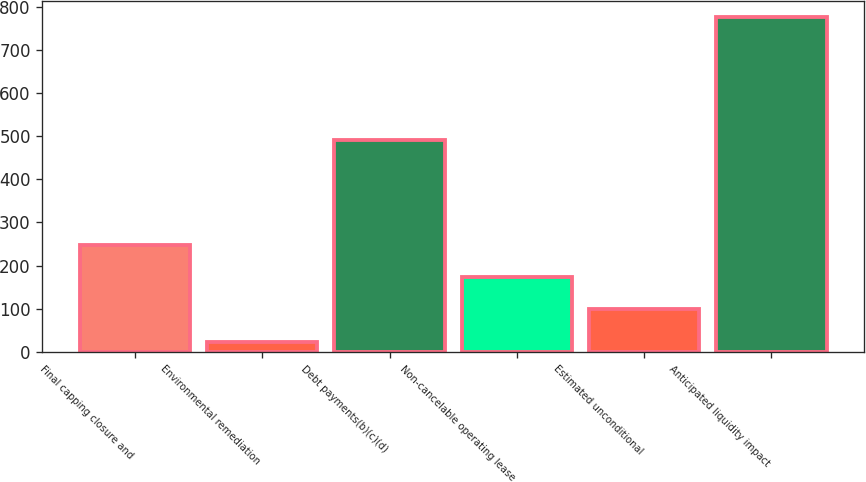Convert chart. <chart><loc_0><loc_0><loc_500><loc_500><bar_chart><fcel>Final capping closure and<fcel>Environmental remediation<fcel>Debt payments(b)(c)(d)<fcel>Non-cancelable operating lease<fcel>Estimated unconditional<fcel>Anticipated liquidity impact<nl><fcel>248.6<fcel>23<fcel>491<fcel>173.4<fcel>98.2<fcel>775<nl></chart> 